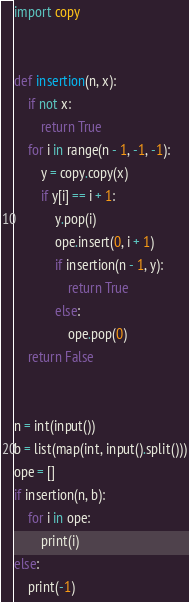<code> <loc_0><loc_0><loc_500><loc_500><_Python_>import copy


def insertion(n, x):
    if not x:
        return True
    for i in range(n - 1, -1, -1):
        y = copy.copy(x)
        if y[i] == i + 1:
            y.pop(i)
            ope.insert(0, i + 1)
            if insertion(n - 1, y):
                return True
            else:
                ope.pop(0)
    return False


n = int(input())
b = list(map(int, input().split()))
ope = []
if insertion(n, b):
    for i in ope:
        print(i)
else:
    print(-1)
</code> 